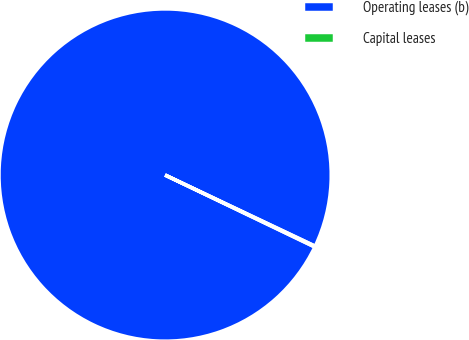Convert chart to OTSL. <chart><loc_0><loc_0><loc_500><loc_500><pie_chart><fcel>Operating leases (b)<fcel>Capital leases<nl><fcel>99.91%<fcel>0.09%<nl></chart> 